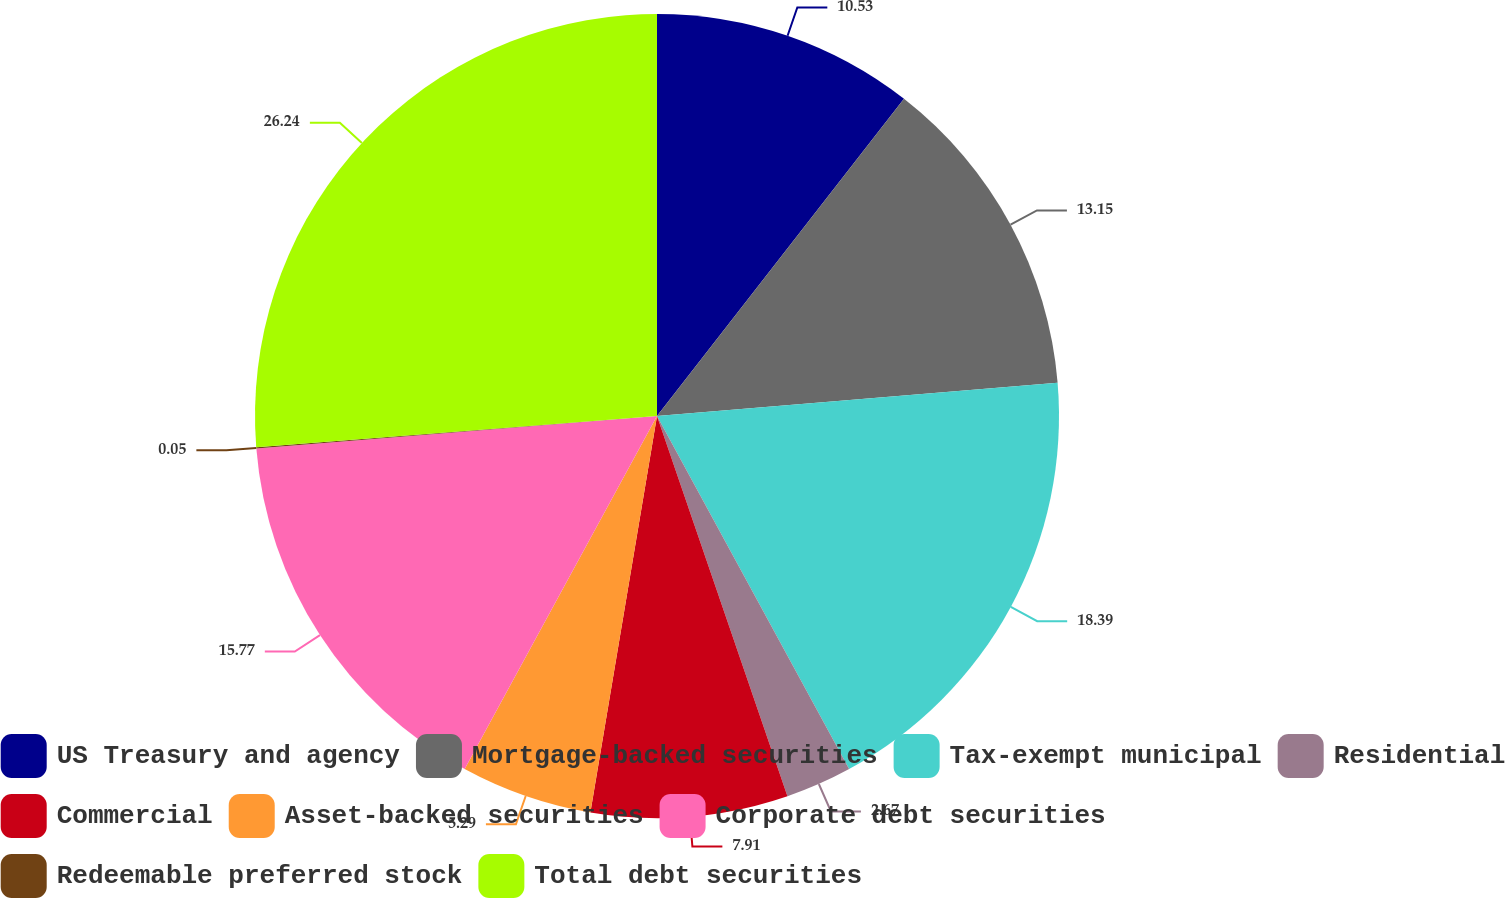Convert chart. <chart><loc_0><loc_0><loc_500><loc_500><pie_chart><fcel>US Treasury and agency<fcel>Mortgage-backed securities<fcel>Tax-exempt municipal<fcel>Residential<fcel>Commercial<fcel>Asset-backed securities<fcel>Corporate debt securities<fcel>Redeemable preferred stock<fcel>Total debt securities<nl><fcel>10.53%<fcel>13.15%<fcel>18.39%<fcel>2.67%<fcel>7.91%<fcel>5.29%<fcel>15.77%<fcel>0.05%<fcel>26.24%<nl></chart> 